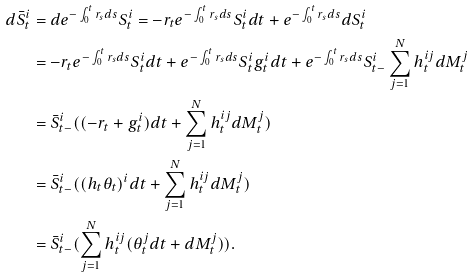Convert formula to latex. <formula><loc_0><loc_0><loc_500><loc_500>d \bar { S } ^ { i } _ { t } & = d e ^ { - \int _ { 0 } ^ { t } r _ { s } d s } S ^ { i } _ { t } = - r _ { t } e ^ { - \int _ { 0 } ^ { t } r _ { s } d s } S ^ { i } _ { t } d t + e ^ { - \int _ { 0 } ^ { t } r _ { s } d s } d S ^ { i } _ { t } \\ & = - r _ { t } e ^ { - \int _ { 0 } ^ { t } r _ { s } d s } S ^ { i } _ { t } d t + e ^ { - \int _ { 0 } ^ { t } r _ { s } d s } S ^ { i } _ { t } g _ { t } ^ { i } d t + e ^ { - \int _ { 0 } ^ { t } r _ { s } d s } S ^ { i } _ { t - } \sum _ { j = 1 } ^ { N } h _ { t } ^ { i j } d M ^ { j } _ { t } \\ & = \bar { S } _ { t - } ^ { i } ( ( - r _ { t } + g _ { t } ^ { i } ) d t + \sum _ { j = 1 } ^ { N } h _ { t } ^ { i j } d M ^ { j } _ { t } ) \\ & = \bar { S } _ { t - } ^ { i } ( ( h _ { t } \theta _ { t } ) ^ { i } d t + \sum _ { j = 1 } ^ { N } h _ { t } ^ { i j } d M ^ { j } _ { t } ) \\ & = \bar { S } ^ { i } _ { t - } ( \sum _ { j = 1 } ^ { N } h _ { t } ^ { i j } ( \theta ^ { j } _ { t } d t + d M ^ { j } _ { t } ) ) .</formula> 